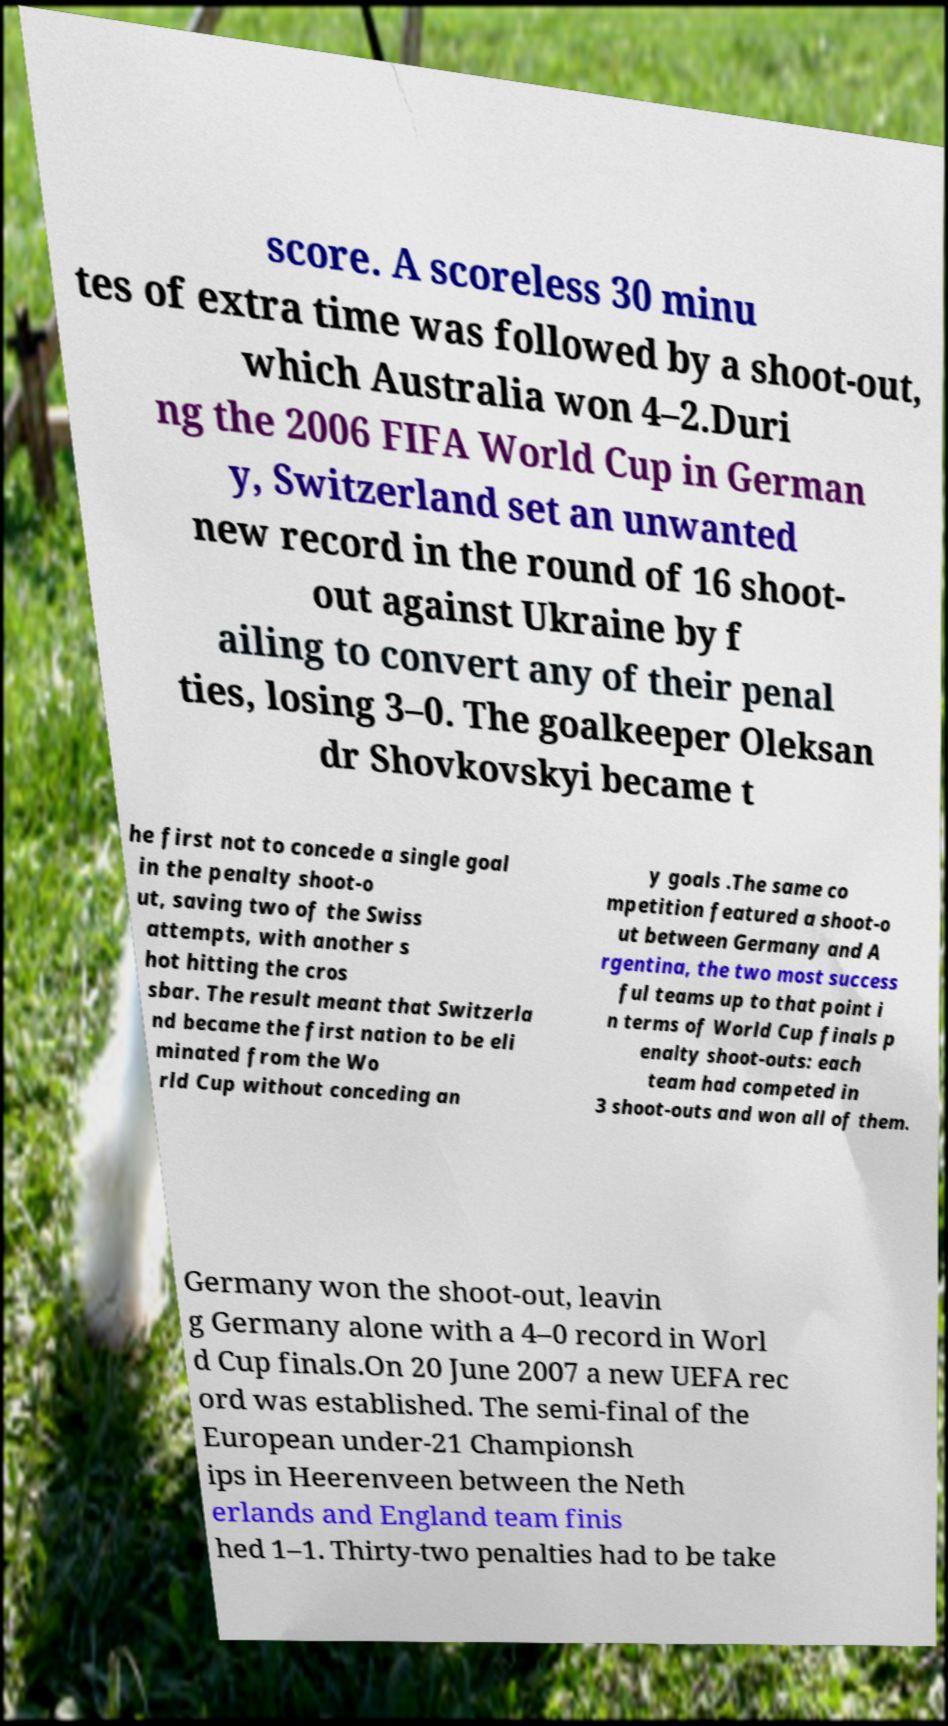Can you accurately transcribe the text from the provided image for me? score. A scoreless 30 minu tes of extra time was followed by a shoot-out, which Australia won 4–2.Duri ng the 2006 FIFA World Cup in German y, Switzerland set an unwanted new record in the round of 16 shoot- out against Ukraine by f ailing to convert any of their penal ties, losing 3–0. The goalkeeper Oleksan dr Shovkovskyi became t he first not to concede a single goal in the penalty shoot-o ut, saving two of the Swiss attempts, with another s hot hitting the cros sbar. The result meant that Switzerla nd became the first nation to be eli minated from the Wo rld Cup without conceding an y goals .The same co mpetition featured a shoot-o ut between Germany and A rgentina, the two most success ful teams up to that point i n terms of World Cup finals p enalty shoot-outs: each team had competed in 3 shoot-outs and won all of them. Germany won the shoot-out, leavin g Germany alone with a 4–0 record in Worl d Cup finals.On 20 June 2007 a new UEFA rec ord was established. The semi-final of the European under-21 Championsh ips in Heerenveen between the Neth erlands and England team finis hed 1–1. Thirty-two penalties had to be take 